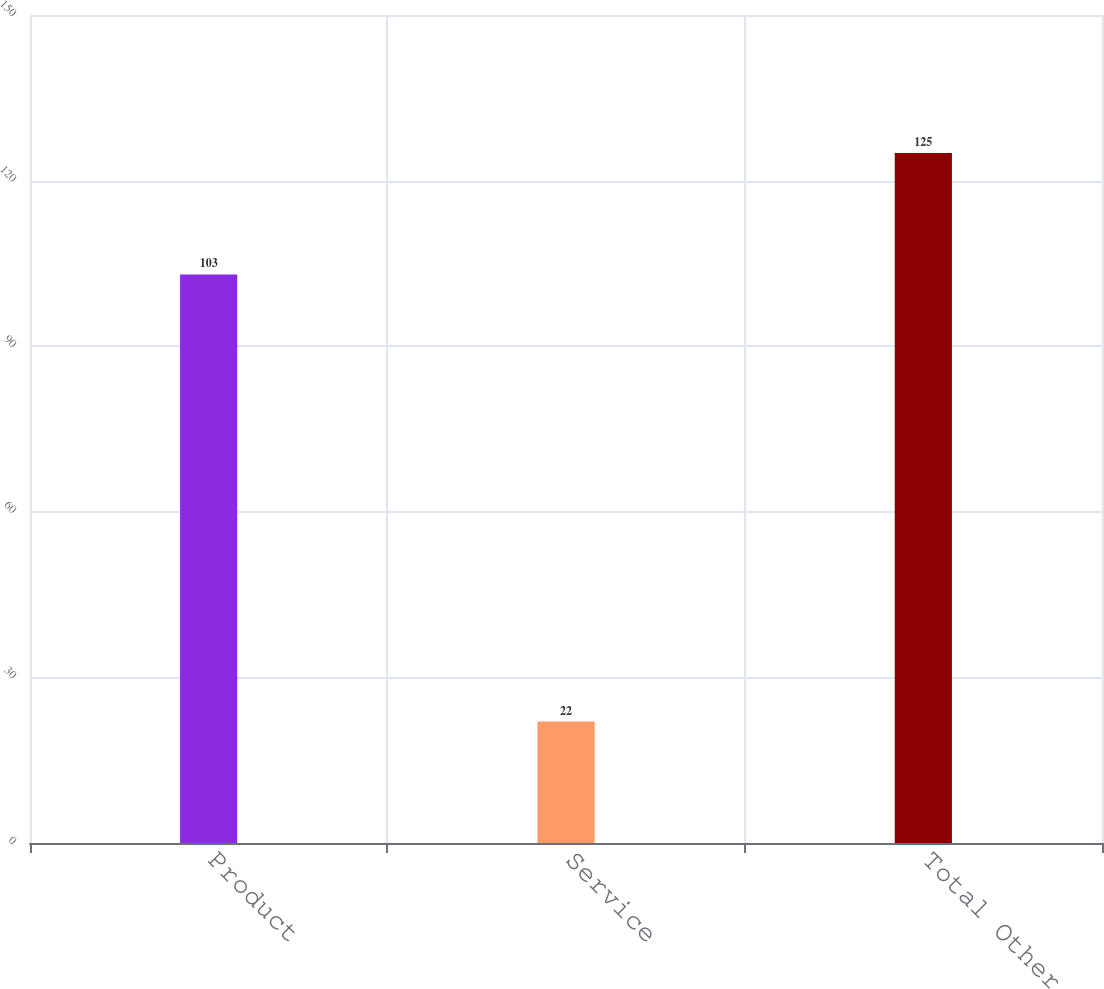Convert chart to OTSL. <chart><loc_0><loc_0><loc_500><loc_500><bar_chart><fcel>Product<fcel>Service<fcel>Total Other<nl><fcel>103<fcel>22<fcel>125<nl></chart> 